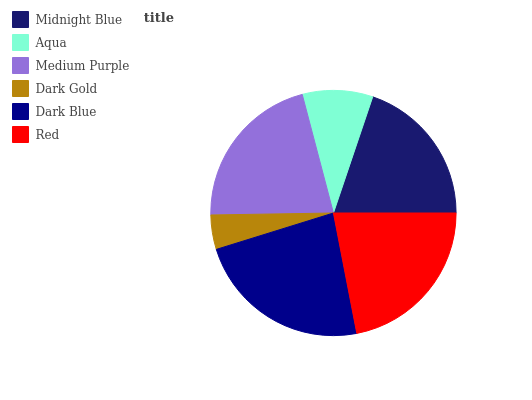Is Dark Gold the minimum?
Answer yes or no. Yes. Is Dark Blue the maximum?
Answer yes or no. Yes. Is Aqua the minimum?
Answer yes or no. No. Is Aqua the maximum?
Answer yes or no. No. Is Midnight Blue greater than Aqua?
Answer yes or no. Yes. Is Aqua less than Midnight Blue?
Answer yes or no. Yes. Is Aqua greater than Midnight Blue?
Answer yes or no. No. Is Midnight Blue less than Aqua?
Answer yes or no. No. Is Medium Purple the high median?
Answer yes or no. Yes. Is Midnight Blue the low median?
Answer yes or no. Yes. Is Dark Gold the high median?
Answer yes or no. No. Is Medium Purple the low median?
Answer yes or no. No. 